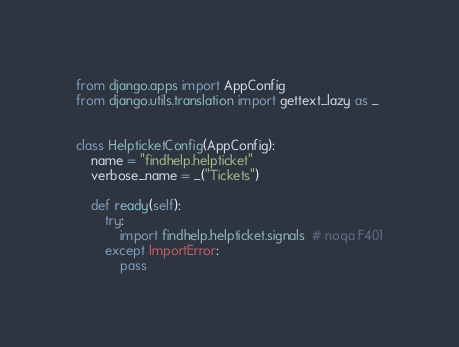Convert code to text. <code><loc_0><loc_0><loc_500><loc_500><_Python_>from django.apps import AppConfig
from django.utils.translation import gettext_lazy as _


class HelpticketConfig(AppConfig):
    name = "findhelp.helpticket"
    verbose_name = _("Tickets")

    def ready(self):
        try:
            import findhelp.helpticket.signals  # noqa F401
        except ImportError:
            pass
</code> 